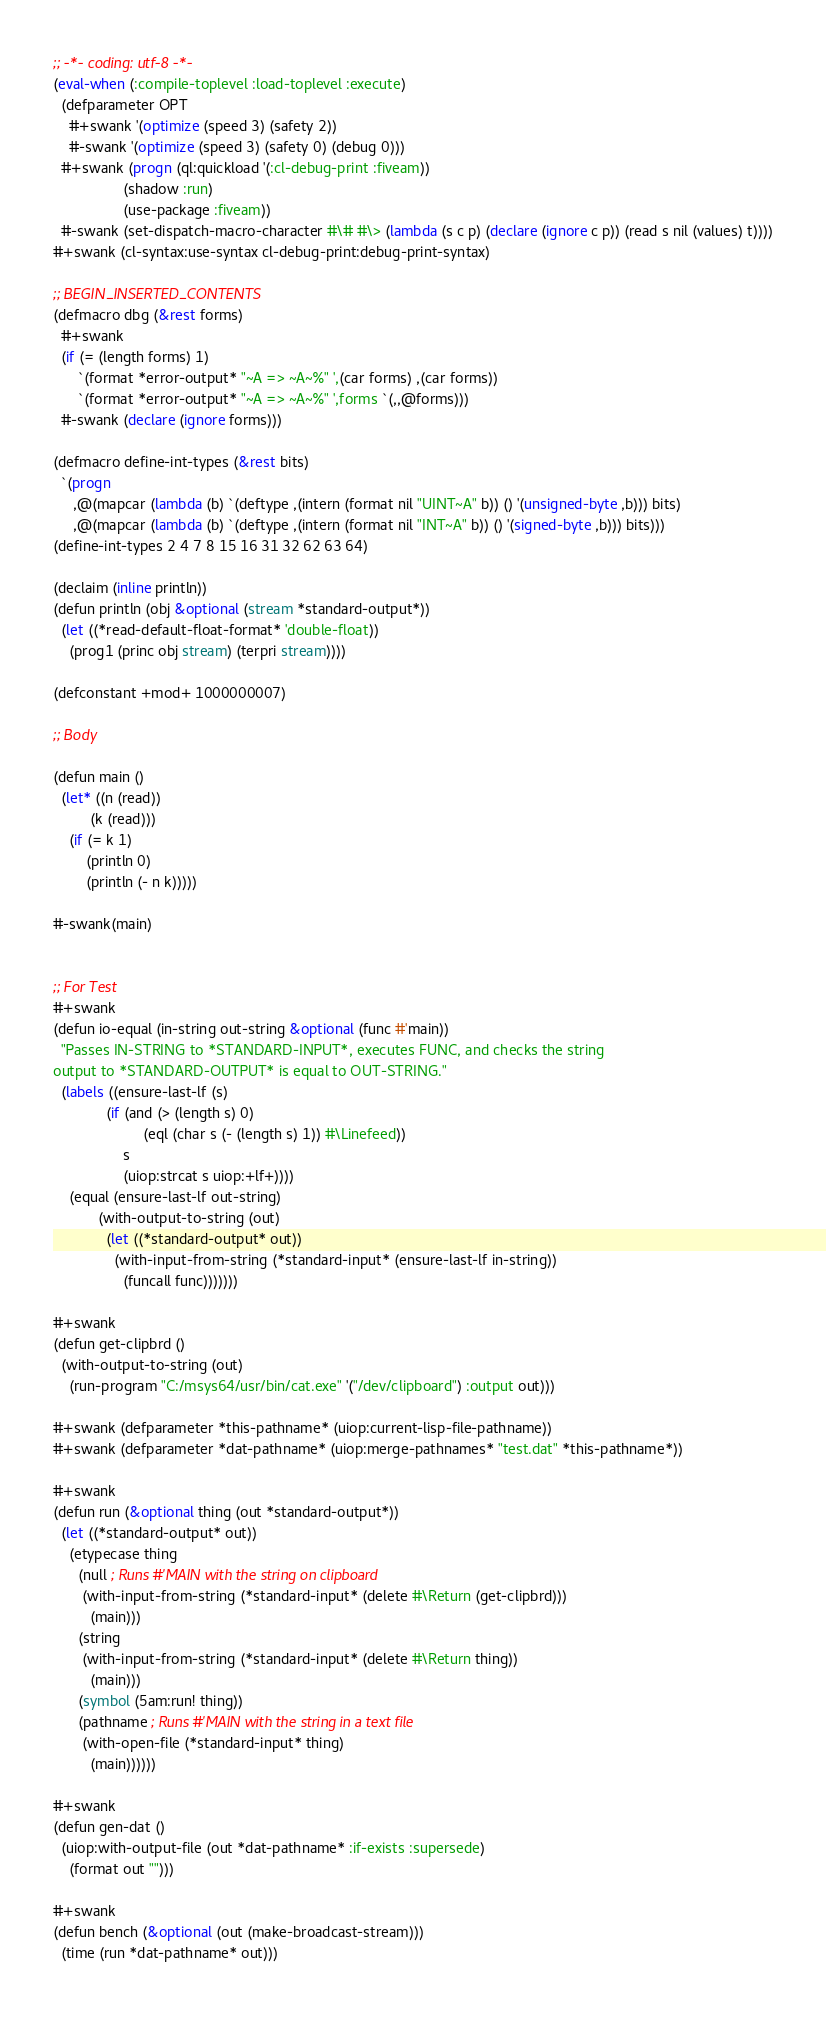<code> <loc_0><loc_0><loc_500><loc_500><_Lisp_>;; -*- coding: utf-8 -*-
(eval-when (:compile-toplevel :load-toplevel :execute)
  (defparameter OPT
    #+swank '(optimize (speed 3) (safety 2))
    #-swank '(optimize (speed 3) (safety 0) (debug 0)))
  #+swank (progn (ql:quickload '(:cl-debug-print :fiveam))
                 (shadow :run)
                 (use-package :fiveam))
  #-swank (set-dispatch-macro-character #\# #\> (lambda (s c p) (declare (ignore c p)) (read s nil (values) t))))
#+swank (cl-syntax:use-syntax cl-debug-print:debug-print-syntax)

;; BEGIN_INSERTED_CONTENTS
(defmacro dbg (&rest forms)
  #+swank
  (if (= (length forms) 1)
      `(format *error-output* "~A => ~A~%" ',(car forms) ,(car forms))
      `(format *error-output* "~A => ~A~%" ',forms `(,,@forms)))
  #-swank (declare (ignore forms)))

(defmacro define-int-types (&rest bits)
  `(progn
     ,@(mapcar (lambda (b) `(deftype ,(intern (format nil "UINT~A" b)) () '(unsigned-byte ,b))) bits)
     ,@(mapcar (lambda (b) `(deftype ,(intern (format nil "INT~A" b)) () '(signed-byte ,b))) bits)))
(define-int-types 2 4 7 8 15 16 31 32 62 63 64)

(declaim (inline println))
(defun println (obj &optional (stream *standard-output*))
  (let ((*read-default-float-format* 'double-float))
    (prog1 (princ obj stream) (terpri stream))))

(defconstant +mod+ 1000000007)

;; Body

(defun main ()
  (let* ((n (read))
         (k (read)))
    (if (= k 1)
        (println 0)
        (println (- n k)))))

#-swank(main)


;; For Test
#+swank
(defun io-equal (in-string out-string &optional (func #'main))
  "Passes IN-STRING to *STANDARD-INPUT*, executes FUNC, and checks the string
output to *STANDARD-OUTPUT* is equal to OUT-STRING."
  (labels ((ensure-last-lf (s)
             (if (and (> (length s) 0)
                      (eql (char s (- (length s) 1)) #\Linefeed))
                 s
                 (uiop:strcat s uiop:+lf+))))
    (equal (ensure-last-lf out-string)
           (with-output-to-string (out)
             (let ((*standard-output* out))
               (with-input-from-string (*standard-input* (ensure-last-lf in-string))
                 (funcall func)))))))

#+swank
(defun get-clipbrd ()
  (with-output-to-string (out)
    (run-program "C:/msys64/usr/bin/cat.exe" '("/dev/clipboard") :output out)))

#+swank (defparameter *this-pathname* (uiop:current-lisp-file-pathname))
#+swank (defparameter *dat-pathname* (uiop:merge-pathnames* "test.dat" *this-pathname*))

#+swank
(defun run (&optional thing (out *standard-output*))
  (let ((*standard-output* out))
    (etypecase thing
      (null ; Runs #'MAIN with the string on clipboard
       (with-input-from-string (*standard-input* (delete #\Return (get-clipbrd)))
         (main)))
      (string
       (with-input-from-string (*standard-input* (delete #\Return thing))
         (main)))
      (symbol (5am:run! thing))
      (pathname ; Runs #'MAIN with the string in a text file
       (with-open-file (*standard-input* thing)
         (main))))))

#+swank
(defun gen-dat ()
  (uiop:with-output-file (out *dat-pathname* :if-exists :supersede)
    (format out "")))

#+swank
(defun bench (&optional (out (make-broadcast-stream)))
  (time (run *dat-pathname* out)))
</code> 